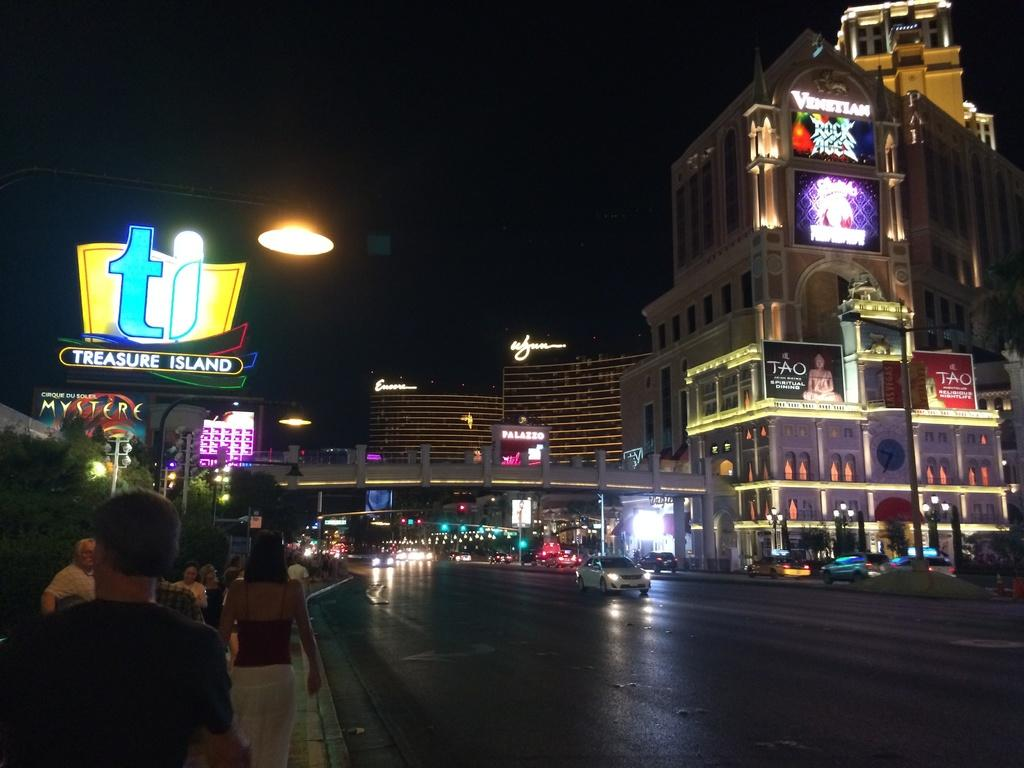What can be seen on the road in the image? There are vehicles on the road in the image. What can be seen on the footpath in the image? There are people on the footpath in the image. How would you describe the sky in the background of the image? The sky in the background of the image is dark. What is visible in the distance behind the vehicles and people in the image? There are many buildings in the background of the image. Can you tell me how many grains of rice are on the footpath in the image? There are no grains of rice present in the image; the image features vehicles on the road and people on the footpath. Can you hear the image crying in the image? There is no person or object in the image that can cry, as it is a still image. 